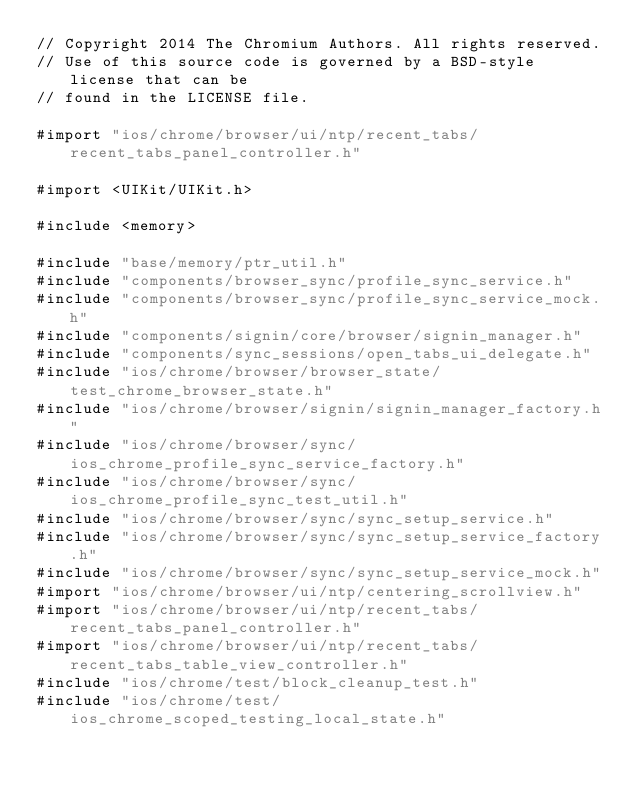Convert code to text. <code><loc_0><loc_0><loc_500><loc_500><_ObjectiveC_>// Copyright 2014 The Chromium Authors. All rights reserved.
// Use of this source code is governed by a BSD-style license that can be
// found in the LICENSE file.

#import "ios/chrome/browser/ui/ntp/recent_tabs/recent_tabs_panel_controller.h"

#import <UIKit/UIKit.h>

#include <memory>

#include "base/memory/ptr_util.h"
#include "components/browser_sync/profile_sync_service.h"
#include "components/browser_sync/profile_sync_service_mock.h"
#include "components/signin/core/browser/signin_manager.h"
#include "components/sync_sessions/open_tabs_ui_delegate.h"
#include "ios/chrome/browser/browser_state/test_chrome_browser_state.h"
#include "ios/chrome/browser/signin/signin_manager_factory.h"
#include "ios/chrome/browser/sync/ios_chrome_profile_sync_service_factory.h"
#include "ios/chrome/browser/sync/ios_chrome_profile_sync_test_util.h"
#include "ios/chrome/browser/sync/sync_setup_service.h"
#include "ios/chrome/browser/sync/sync_setup_service_factory.h"
#include "ios/chrome/browser/sync/sync_setup_service_mock.h"
#import "ios/chrome/browser/ui/ntp/centering_scrollview.h"
#import "ios/chrome/browser/ui/ntp/recent_tabs/recent_tabs_panel_controller.h"
#import "ios/chrome/browser/ui/ntp/recent_tabs/recent_tabs_table_view_controller.h"
#include "ios/chrome/test/block_cleanup_test.h"
#include "ios/chrome/test/ios_chrome_scoped_testing_local_state.h"</code> 